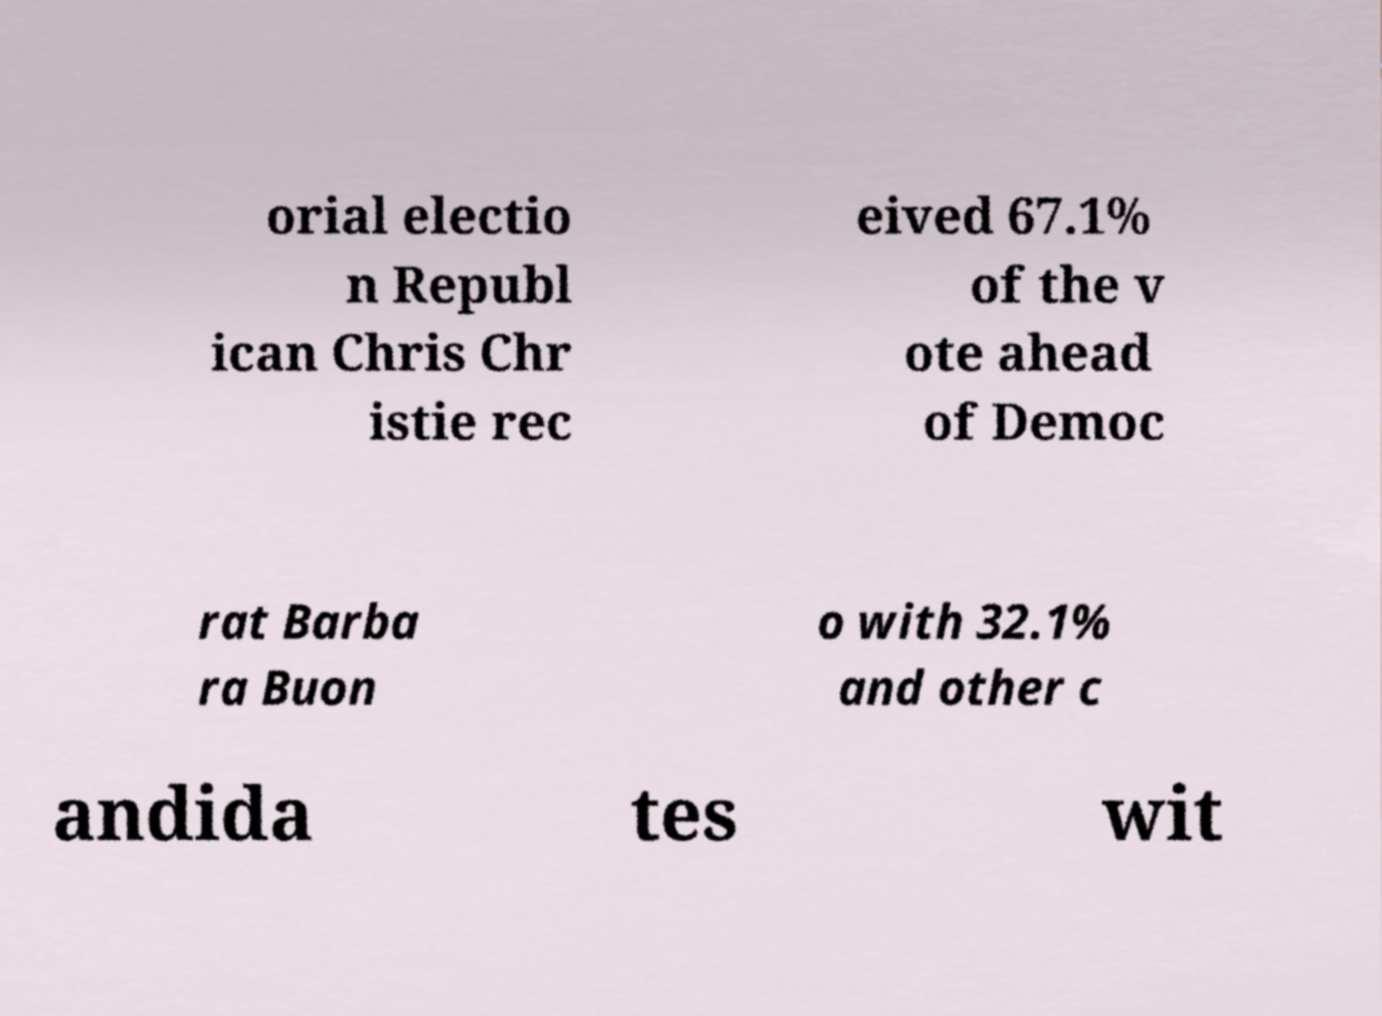Please read and relay the text visible in this image. What does it say? orial electio n Republ ican Chris Chr istie rec eived 67.1% of the v ote ahead of Democ rat Barba ra Buon o with 32.1% and other c andida tes wit 